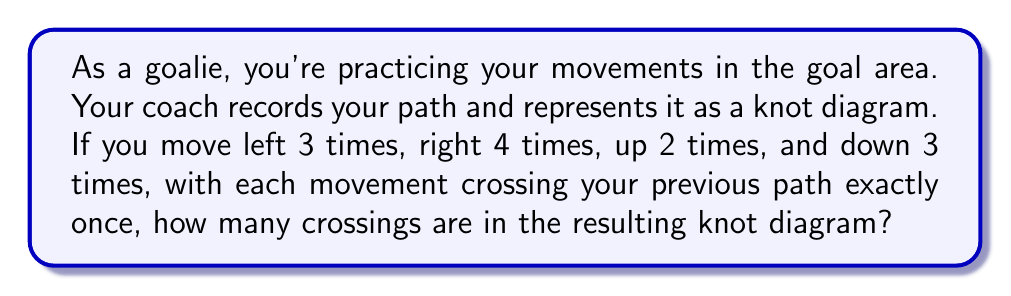Could you help me with this problem? Let's approach this step-by-step:

1) First, we need to understand what contributes to crossings in the knot diagram:
   - Each time a movement intersects with a previous path, it creates a crossing.

2) Now, let's count the crossings created by each movement:
   - Left movements (3 times): 
     The first left doesn't cross anything.
     The second left crosses 1 previous path.
     The third left crosses 2 previous paths.
     Total crossings from left movements: $0 + 1 + 2 = 3$

   - Right movements (4 times):
     Each right movement crosses all previous left movements and any previous right movements.
     So we have: $3 + 4 + 5 + 6 = 18$ crossings

   - Up movements (2 times):
     Each up movement crosses all previous horizontal (left and right) movements.
     So we have: $7 + 8 = 15$ crossings

   - Down movements (3 times):
     Each down movement crosses all previous horizontal movements and up movements.
     So we have: $9 + 10 + 11 = 30$ crossings

3) To get the total number of crossings, we sum all these up:
   $$ \text{Total crossings} = 3 + 18 + 15 + 30 = 66 $$

Therefore, the resulting knot diagram has 66 crossings.
Answer: 66 